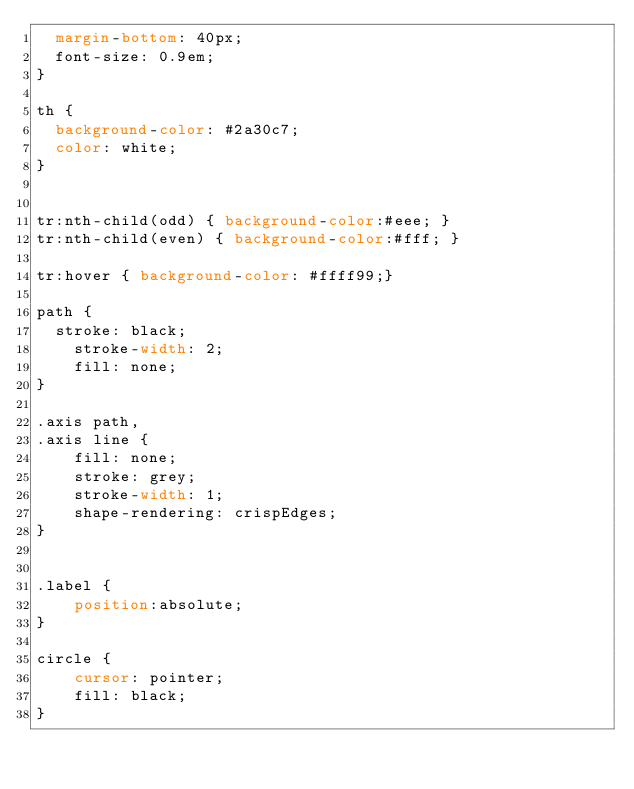Convert code to text. <code><loc_0><loc_0><loc_500><loc_500><_CSS_>  margin-bottom: 40px;
  font-size: 0.9em;
}

th {
  background-color: #2a30c7;
  color: white;
}


tr:nth-child(odd) { background-color:#eee; }
tr:nth-child(even) { background-color:#fff; }

tr:hover { background-color: #ffff99;}

path { 
  stroke: black;
	stroke-width: 2;
	fill: none;
}

.axis path,
.axis line {
	fill: none;
	stroke: grey;
	stroke-width: 1;
	shape-rendering: crispEdges;
}


.label {
    position:absolute;
}

circle {
    cursor: pointer;
    fill: black;
}
</code> 